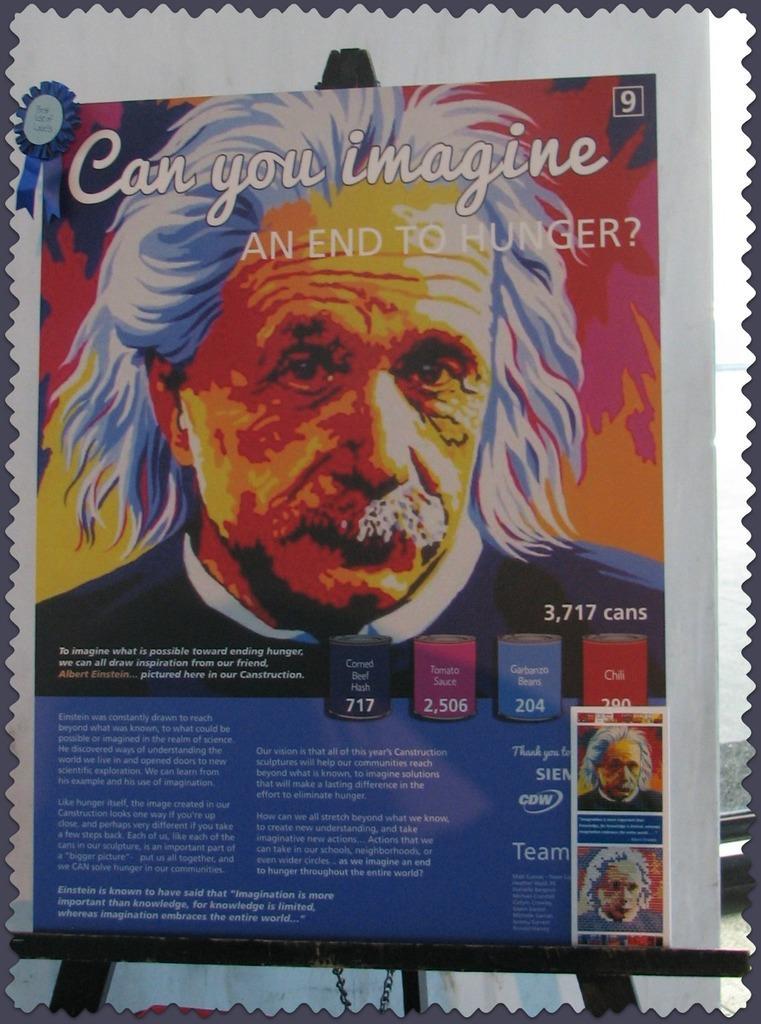Could you give a brief overview of what you see in this image? In this image I can see a hoarding with some text and images of the people. 